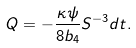<formula> <loc_0><loc_0><loc_500><loc_500>Q = - \frac { \kappa \psi } { 8 b _ { 4 } } S ^ { - 3 } d t .</formula> 